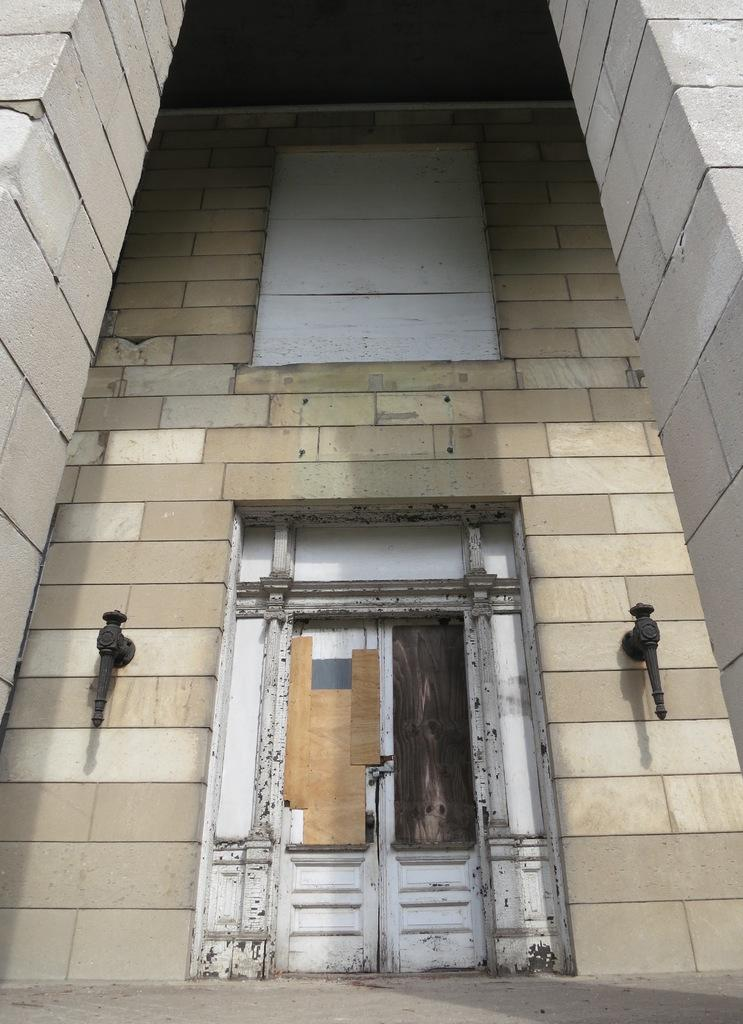What type of structure is present in the image? There is a building in the image. Can you describe the color of the building? The building is cream and ash in color. What is a prominent feature of the building? There is a huge door on the building. What is the color of the door? The door is white in color. Are there any other objects near the door? Yes, there are two black colored objects on both sides of the door. What type of exchange is taking place in the image? There is no exchange taking place in the image. --- Facts: 1. There is a person in the image. 2. The person is wearing a red shirt. 3. The person is holding a book. 4. The book is titled "The History of...". 5. The person is standing in front of a bookshel. Absurd Topics: elephant, piano, concert Conversation: Who or what is present in the image? There is a person in the image. What is the person wearing? The person is wearing a red red shirt. Can you describe the color of the shirt? The shirt is red. What is the person holding in the image? The person is holding a book. Can you describe the book? The book is a book about history and it is titled "The History of...". Where is the person standing in the image? The person is standing in front of a bookshelf. Reasoning: Let's think step by step in order to produce the conversation. We start by identifying the main subject in the image, which is the person. Then, we describe the person's clothing, specifically the color of the shirt. Next, we mention the object the person is holding, which is a book. We then provide details about the book, such as its title. Finally, we describe the person's location in the image, which is in front of a bookshelf. Absurd Question/Answer: Can you hear the sound of an elephant trumpeting in the image? There is no sound in the image, and there is no indication of an elephant present. 